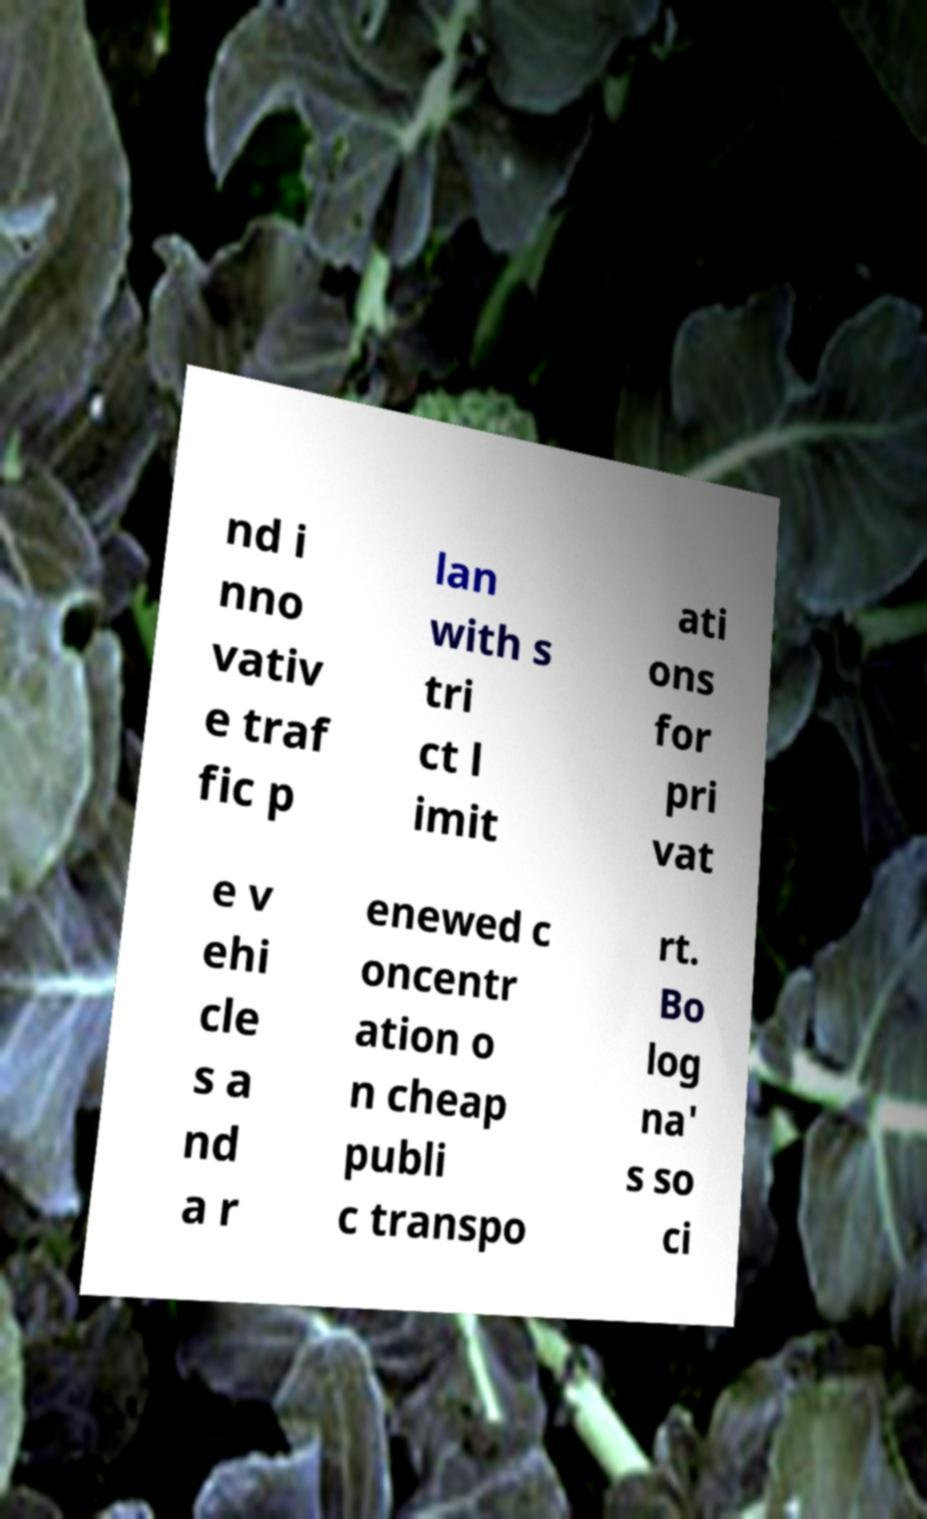Please identify and transcribe the text found in this image. nd i nno vativ e traf fic p lan with s tri ct l imit ati ons for pri vat e v ehi cle s a nd a r enewed c oncentr ation o n cheap publi c transpo rt. Bo log na' s so ci 